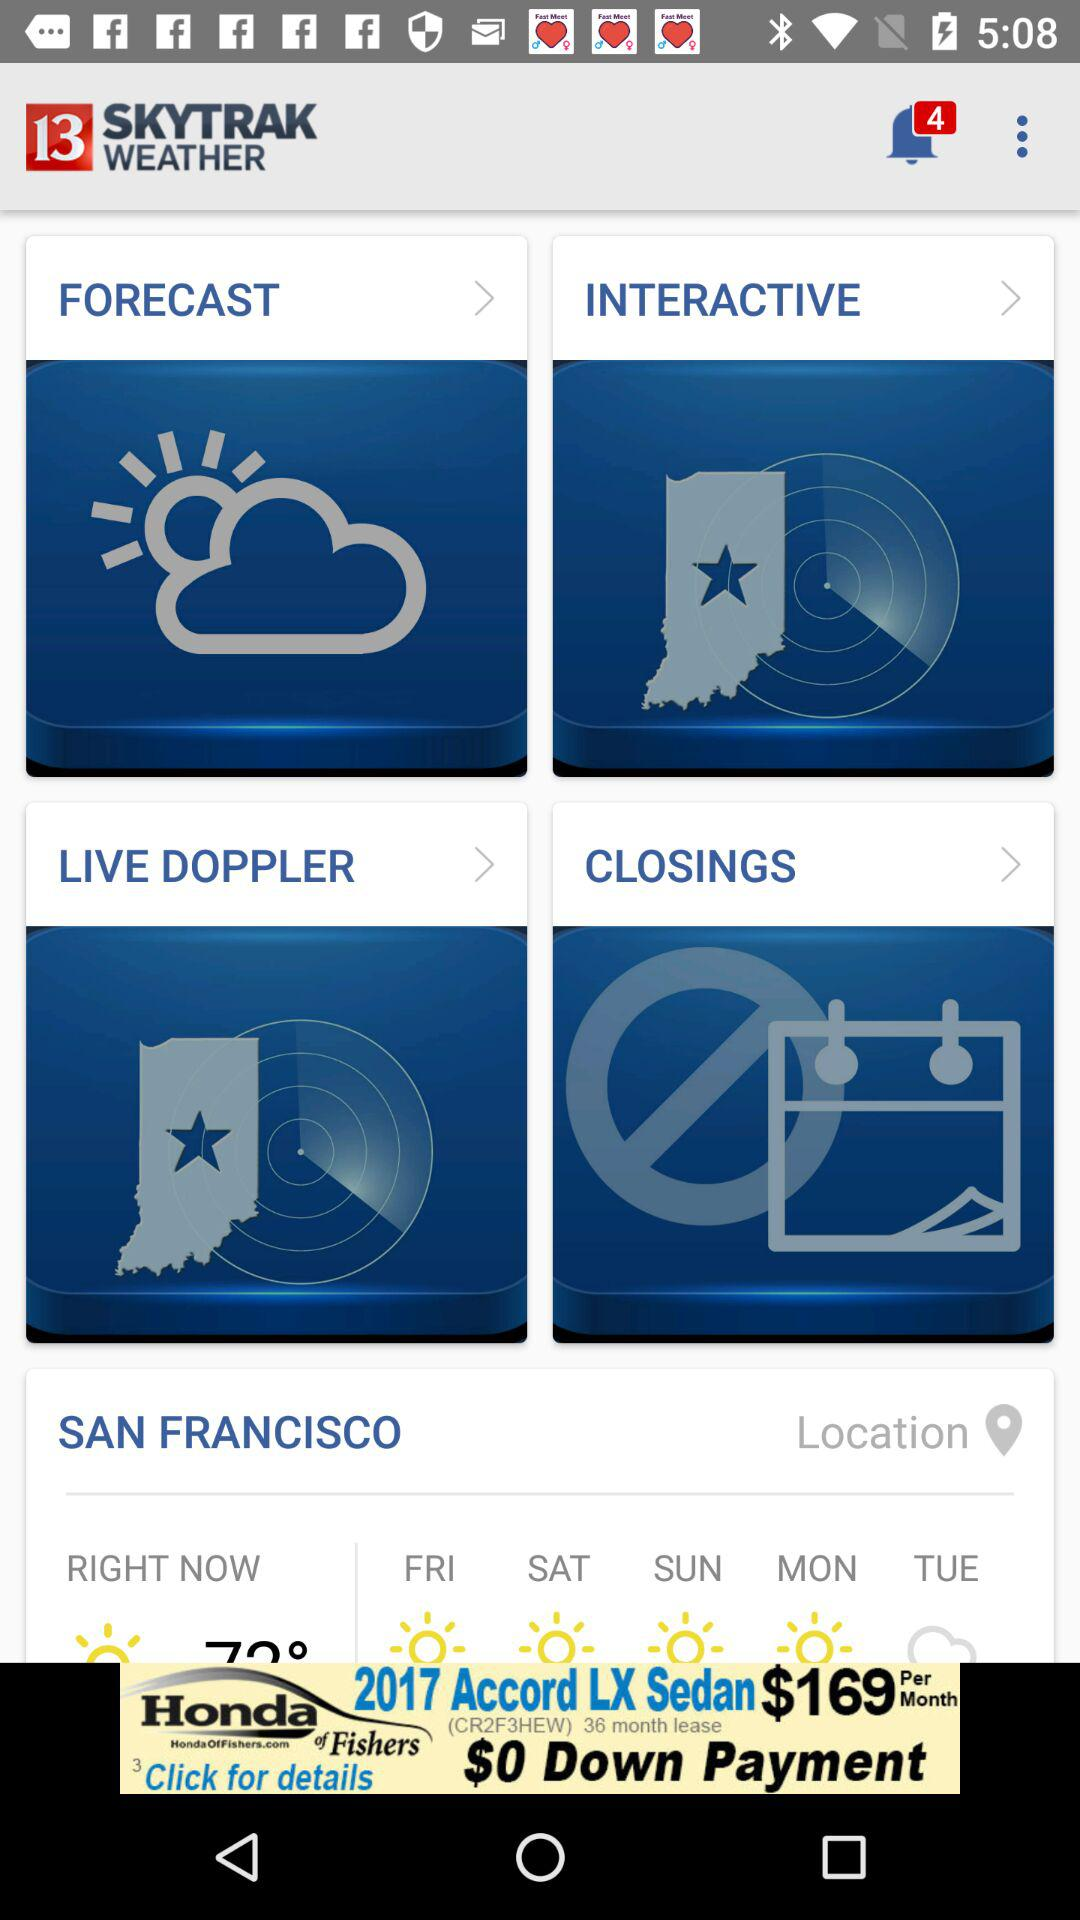What is the number of unread notifications? The unread notifications are 4. 